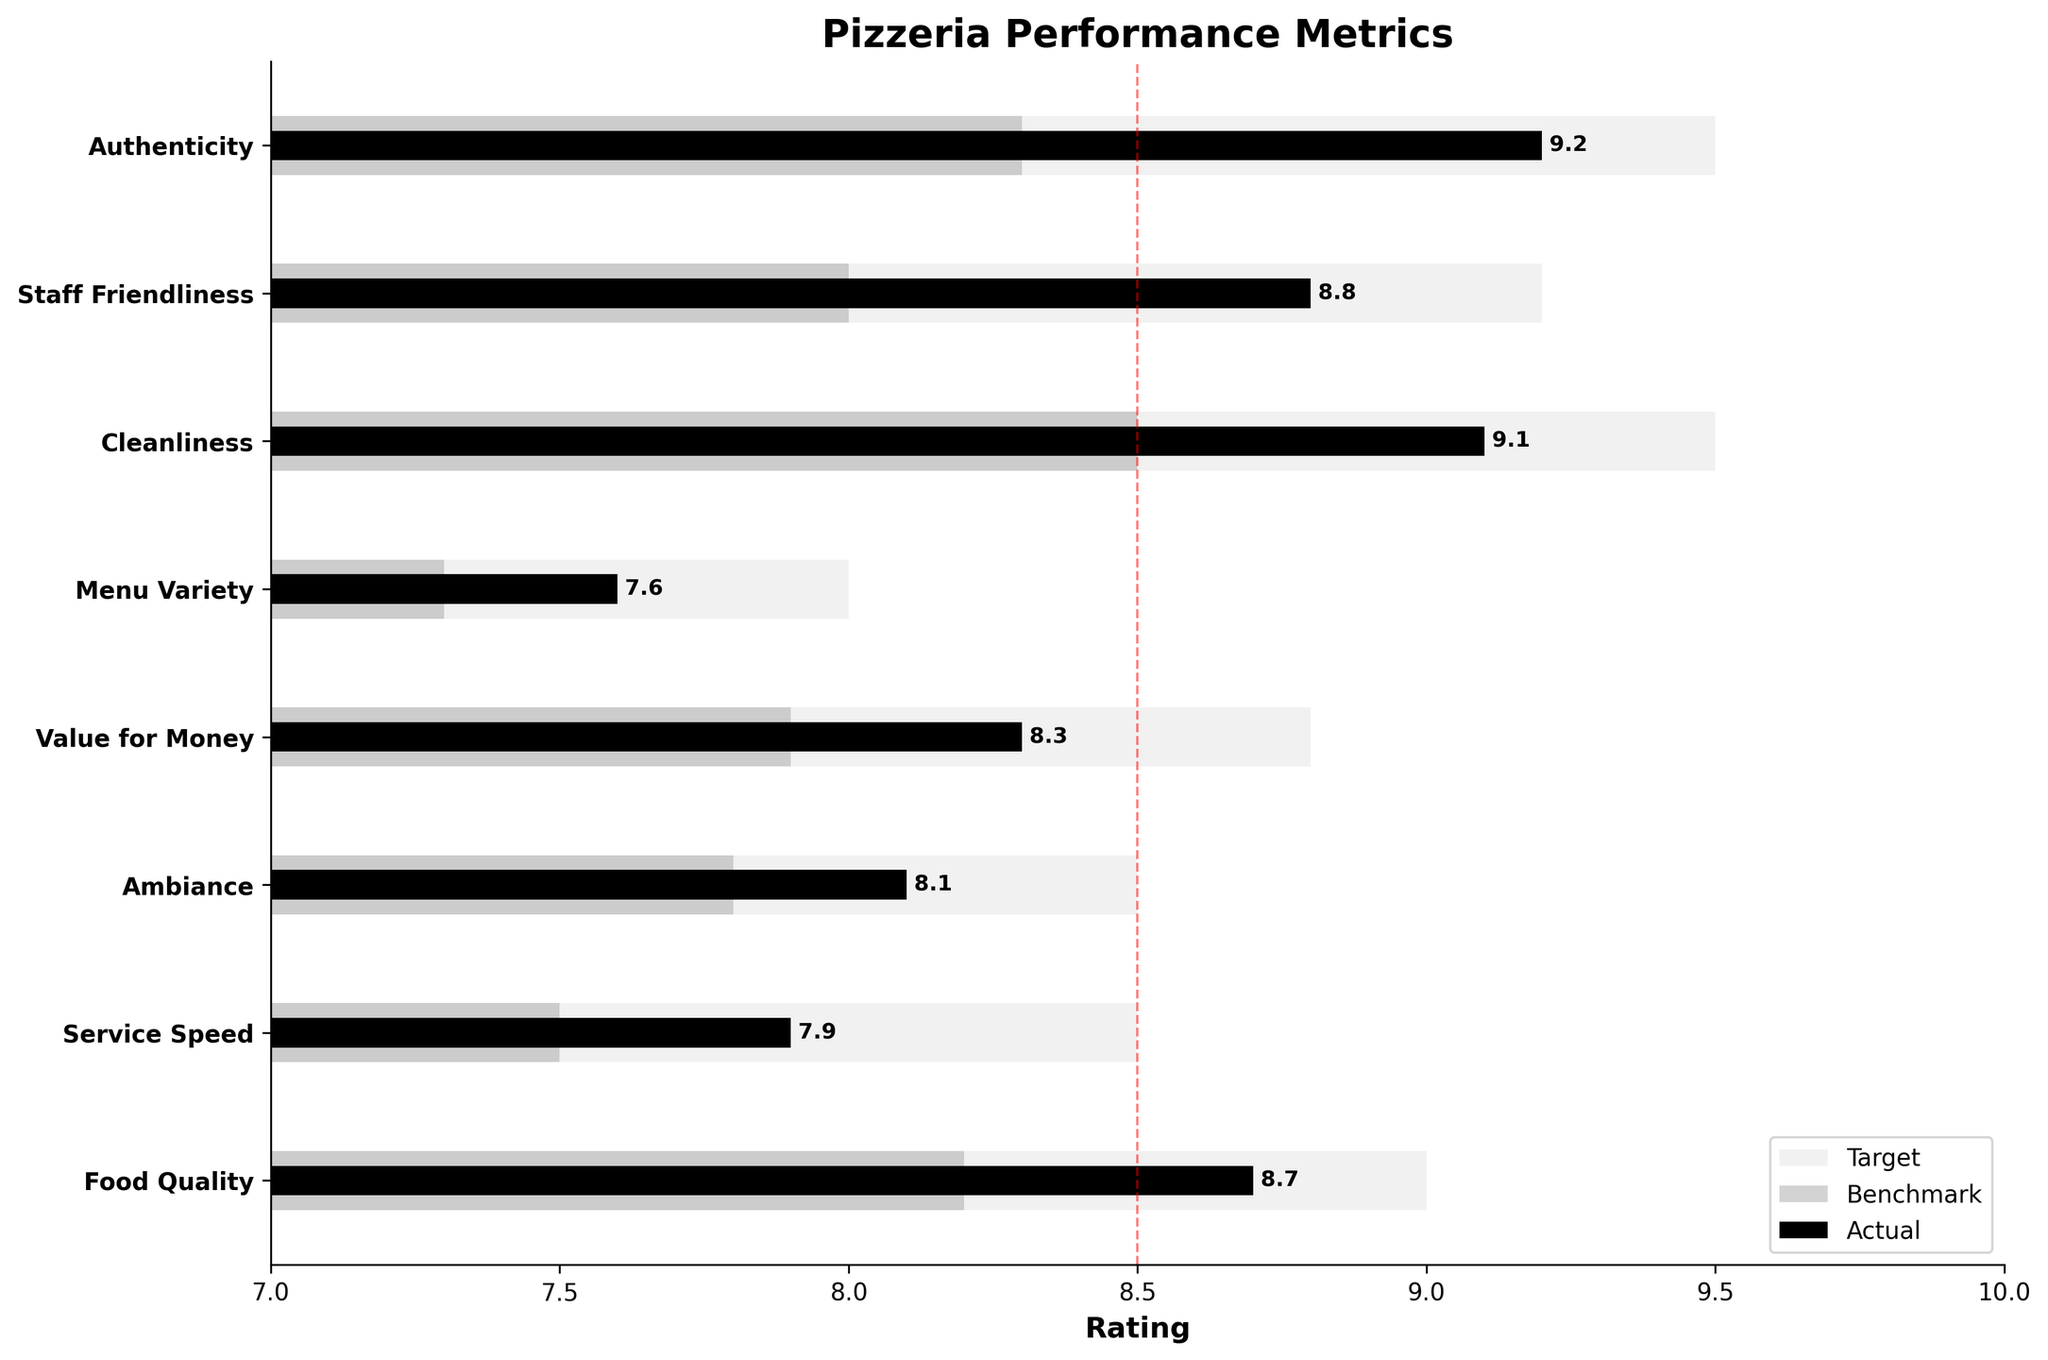What is the title of the chart? The title is usually displayed at the top of the chart, which in this case is "Pizzeria Performance Metrics".
Answer: Pizzeria Performance Metrics What aspect has the highest actual rating? By looking at the length of the bars in the "Actual" (black) section, the aspect with the highest actual rating is "Authenticity" at 9.2.
Answer: Authenticity Which aspect has the lowest actual rating? Observing the actual ratings (black bars), the lowest rating is for "Menu Variety" at 7.6.
Answer: Menu Variety How does the actual rating for "Food Quality" compare to its benchmark and target? The actual rating for "Food Quality" is 8.7, which is higher than the benchmark of 8.2 but slightly below the target of 9.0.
Answer: Higher than benchmark, lower than target How many aspects have an actual rating that exceeds the industry benchmark? By comparing the black bars (actual ratings) to the dark gray bars (benchmarks), the aspects that exceed their benchmark ratings are: "Food Quality", "Service Speed", "Ambiance", "Value for Money", "Cleanliness", "Staff Friendliness", and "Authenticity"—making it seven aspects.
Answer: Seven What is the difference between the actual rating and the target for "Cleanliness"? The actual rating for "Cleanliness" is 9.1, and the target is 9.5. The difference is 9.5 - 9.1 = 0.4.
Answer: 0.4 What is the average actual rating of all aspects? The actual ratings are 8.7, 7.9, 8.1, 8.3, 7.6, 9.1, 8.8, and 9.2. The sum is 67.7, so the average is 67.7 / 8 = 8.4625.
Answer: 8.46 Which aspect is closest to meeting its target rating? By observing the difference between actual ratings (black bars) and target ratings (light gray bars), "Authenticity" has an actual rating of 9.2 and a target of 9.5, making the difference 0.3, the smallest among all aspects.
Answer: Authenticity Which aspect improved the most compared to the benchmark? The difference from benchmark (dark gray bars) to actual (black bars) can be calculated for each aspect; "Staff Friendliness" improved from 8.0 to 8.8, which is an increase of 0.8, the highest improvement among all aspects.
Answer: Staff Friendliness Does any aspect meet or exceed the target rating? By examining the actual ratings (black bars) against the targets (light gray bars), none of the actual ratings meet or exceed the target ratings.
Answer: No 